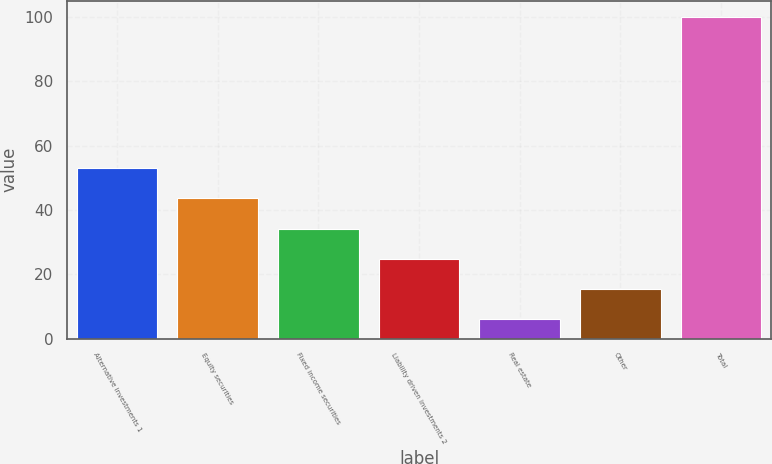Convert chart to OTSL. <chart><loc_0><loc_0><loc_500><loc_500><bar_chart><fcel>Alternative investments 1<fcel>Equity securities<fcel>Fixed income securities<fcel>Liability driven investments 2<fcel>Real estate<fcel>Other<fcel>Total<nl><fcel>53<fcel>43.6<fcel>34.2<fcel>24.8<fcel>6<fcel>15.4<fcel>100<nl></chart> 